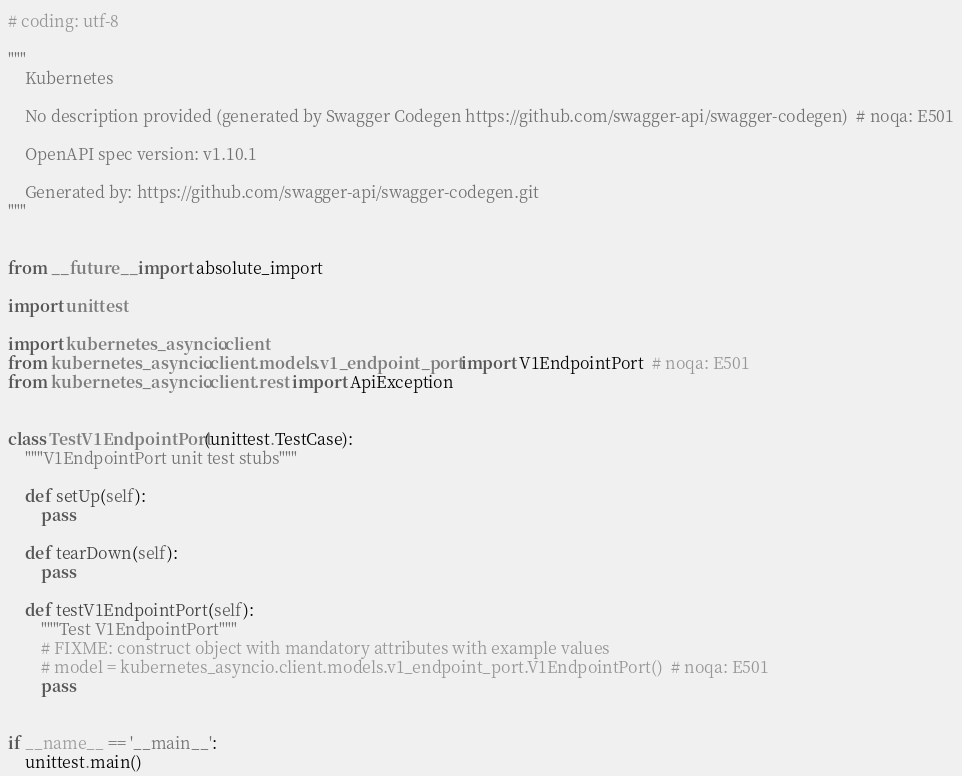Convert code to text. <code><loc_0><loc_0><loc_500><loc_500><_Python_># coding: utf-8

"""
    Kubernetes

    No description provided (generated by Swagger Codegen https://github.com/swagger-api/swagger-codegen)  # noqa: E501

    OpenAPI spec version: v1.10.1
    
    Generated by: https://github.com/swagger-api/swagger-codegen.git
"""


from __future__ import absolute_import

import unittest

import kubernetes_asyncio.client
from kubernetes_asyncio.client.models.v1_endpoint_port import V1EndpointPort  # noqa: E501
from kubernetes_asyncio.client.rest import ApiException


class TestV1EndpointPort(unittest.TestCase):
    """V1EndpointPort unit test stubs"""

    def setUp(self):
        pass

    def tearDown(self):
        pass

    def testV1EndpointPort(self):
        """Test V1EndpointPort"""
        # FIXME: construct object with mandatory attributes with example values
        # model = kubernetes_asyncio.client.models.v1_endpoint_port.V1EndpointPort()  # noqa: E501
        pass


if __name__ == '__main__':
    unittest.main()
</code> 